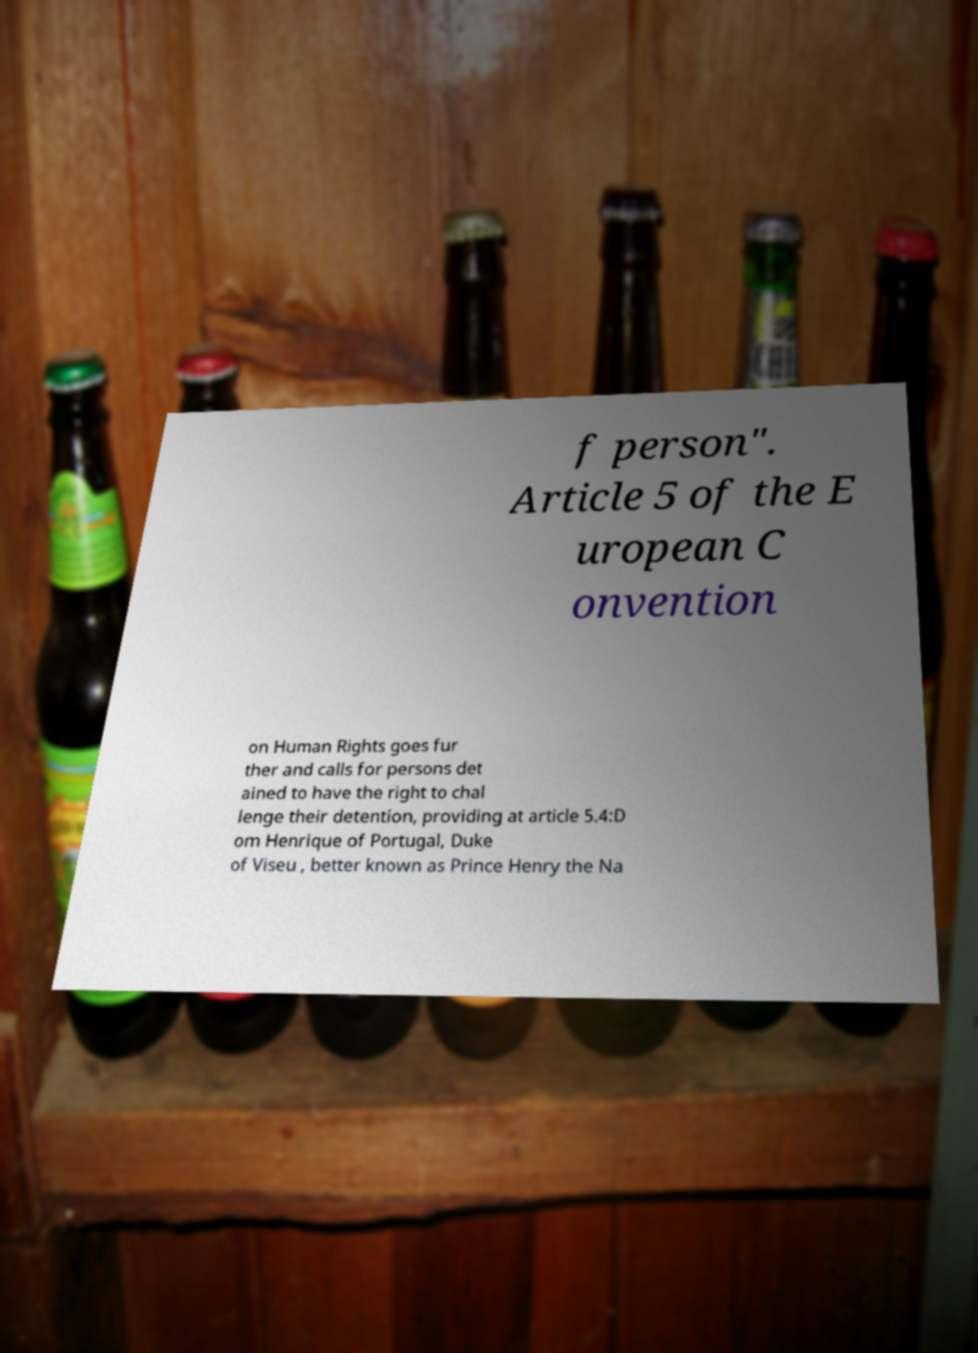There's text embedded in this image that I need extracted. Can you transcribe it verbatim? f person". Article 5 of the E uropean C onvention on Human Rights goes fur ther and calls for persons det ained to have the right to chal lenge their detention, providing at article 5.4:D om Henrique of Portugal, Duke of Viseu , better known as Prince Henry the Na 